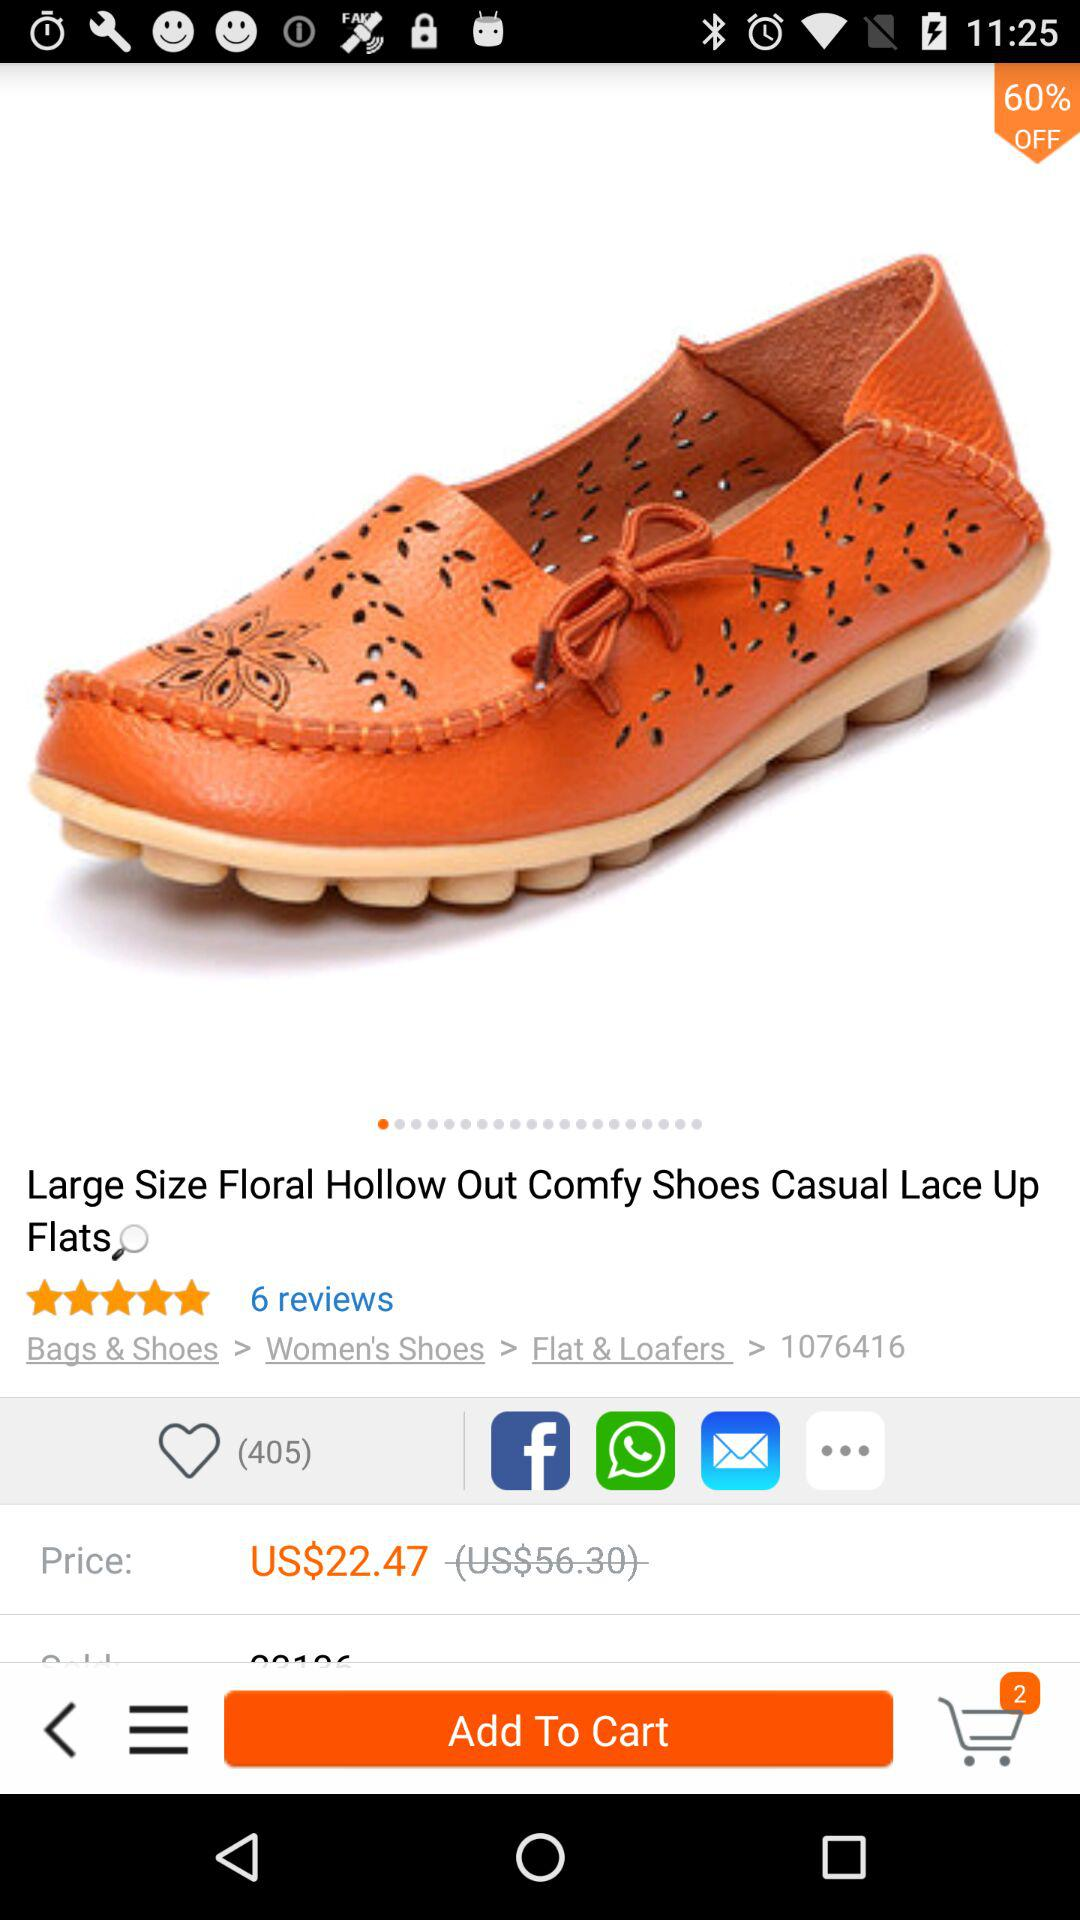How many likes are given to casual lace up flats? There are 405 likes given to casual lace up flats. 